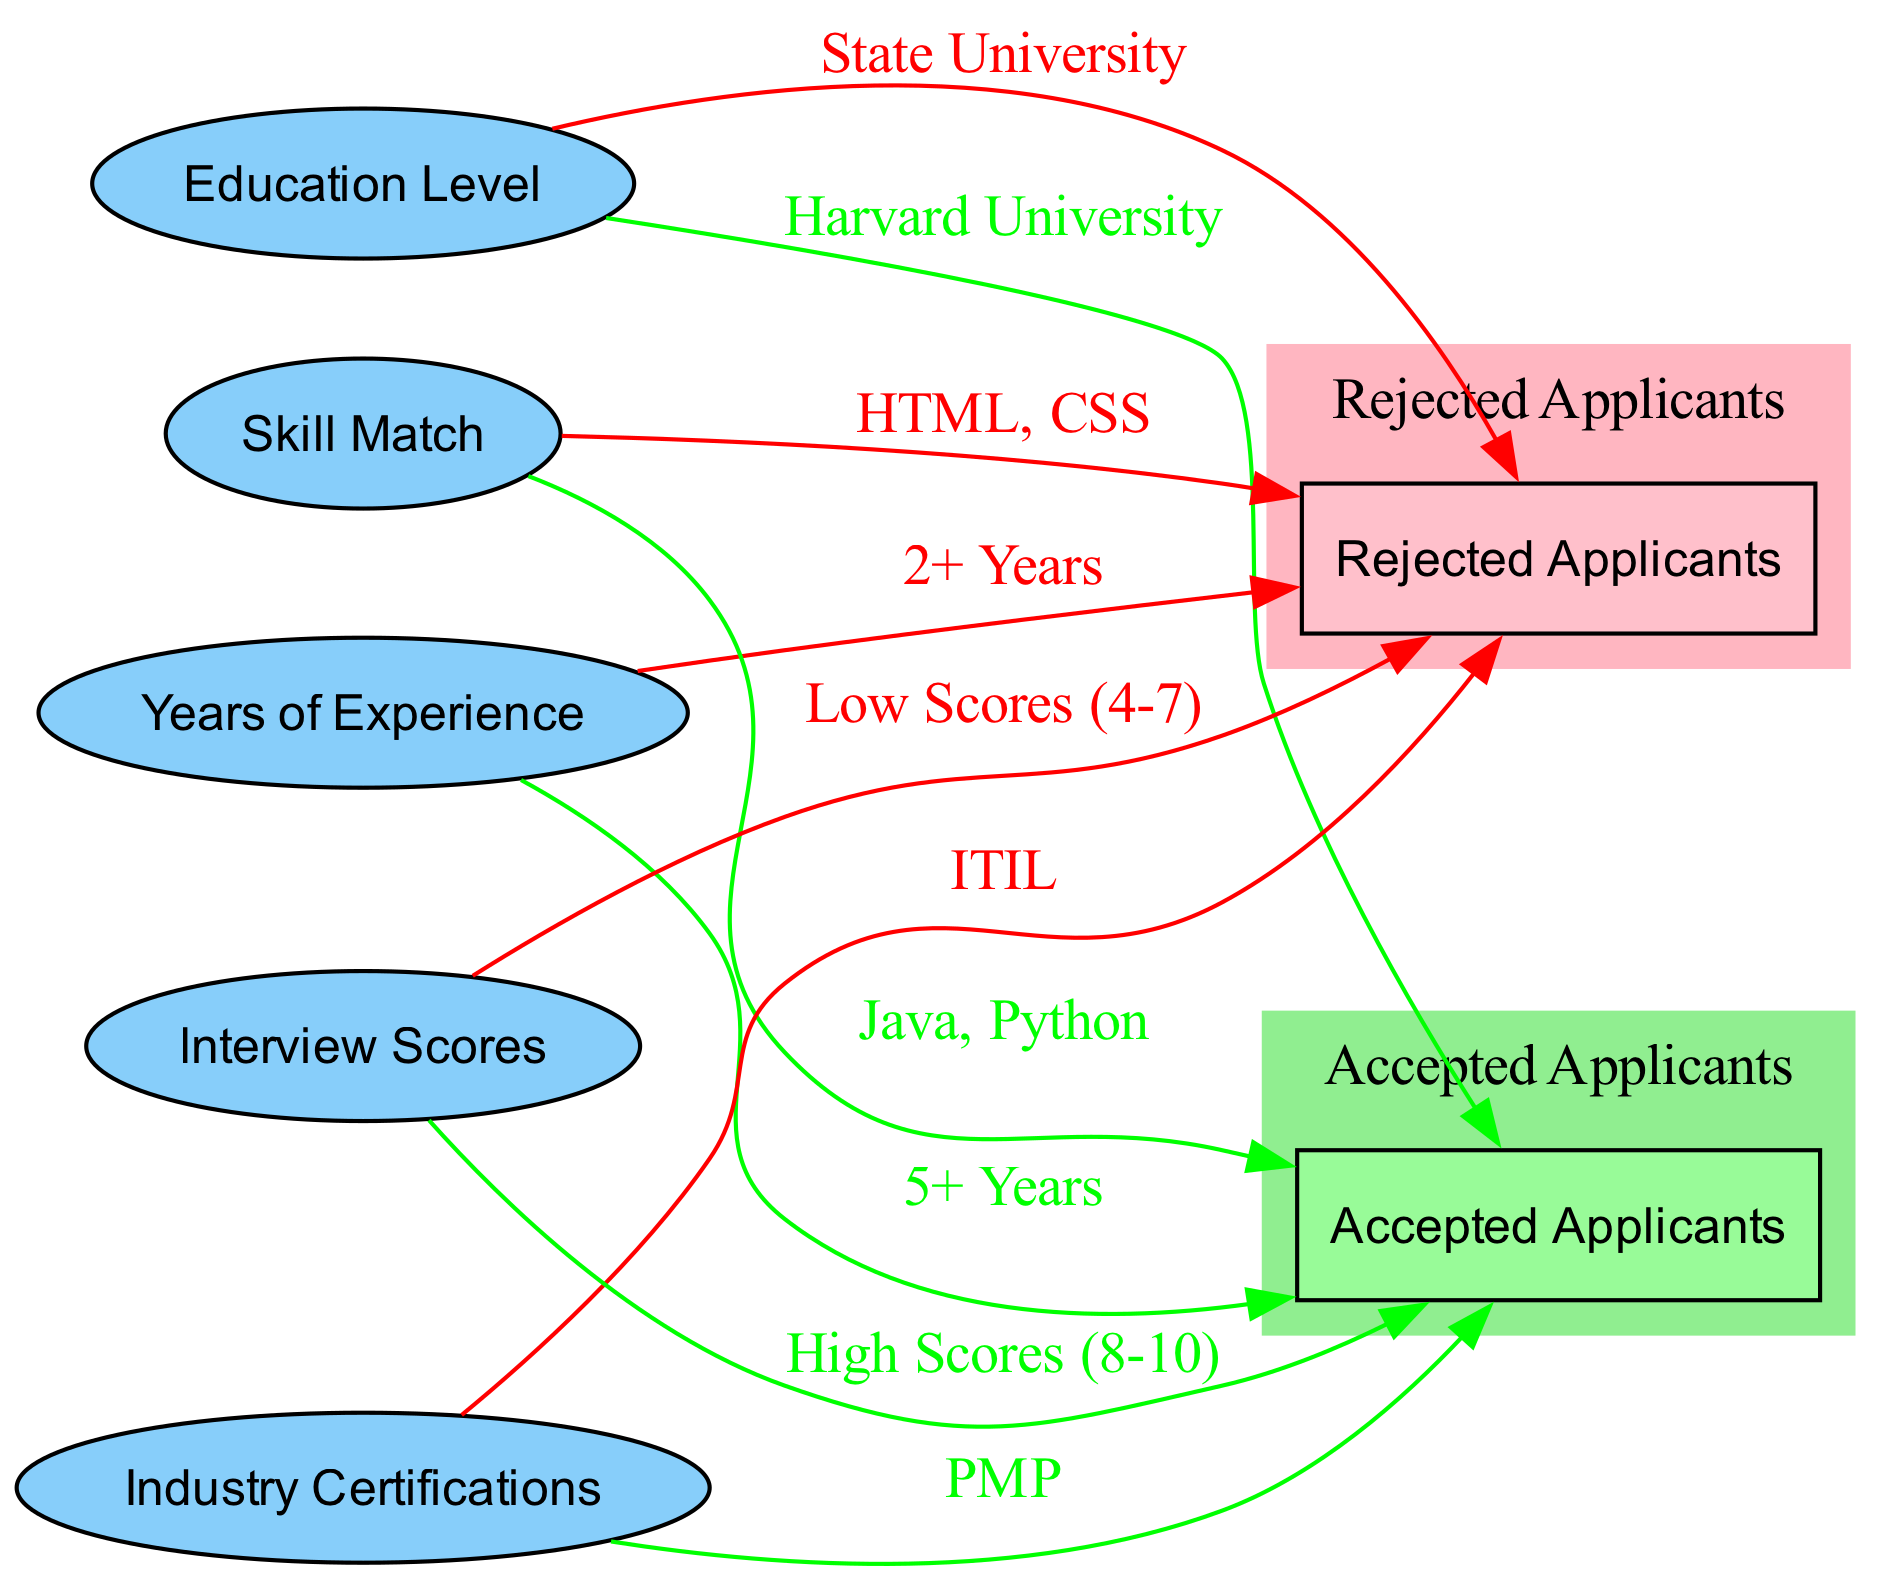What education level is associated with rejected applicants? The diagram indicates that the education level linked to rejected applicants is "State University," as shown by the edge connecting the education_level node to the rejected_applicants node with that label.
Answer: State University What is the years of experience required for accepted applicants? Upon examining the diagram, it shows that accepted applicants are linked to having "5+ Years" of experience, which is denoted by the edge from the years_of_experience node to the accepted_applicants node.
Answer: 5+ Years How many skill matches are associated with rejected applicants? The diagram displays one skill match related to rejected applicants, namely "HTML, CSS," identified by the single edge connecting the skill_match node to the rejected_applicants node.
Answer: 1 Which industry certification is linked to accepted applicants? According to the diagram, the industry certification associated with accepted applicants is "PMP," indicated by the edge from the industry_certifications node to the accepted_applicants.
Answer: PMP Compare the interview scores for both applicant groups. What scores are indicated for rejected applicants? The diagram reveals that rejected applicants are characterized by "Low Scores (4-7)," shown with the edge leading to the rejected_applicants node from the interview_scores node labeled as such.
Answer: Low Scores (4-7) What characteristic is shared between all applicants who were rejected? The diagram explicitly points to "State University" as the education level shared by all rejected applicants, linking through the education_level metric.
Answer: State University What skill set is a distinctive marker for accepted applicants? The diagram indicates that the skill set that distinctly marks accepted applicants is "Java, Python," as indicated by the edge from the skill_match node to the accepted_applicants node with that label.
Answer: Java, Python What is the main difference in interview scores between rejected and accepted applicants? The diagram shows a clear distinction where rejected applicants have "Low Scores (4-7)," while accepted applicants are indicated to have "High Scores (8-10)." This comparison highlights the contrasting evaluation results.
Answer: Low Scores (4-7) vs High Scores (8-10) 